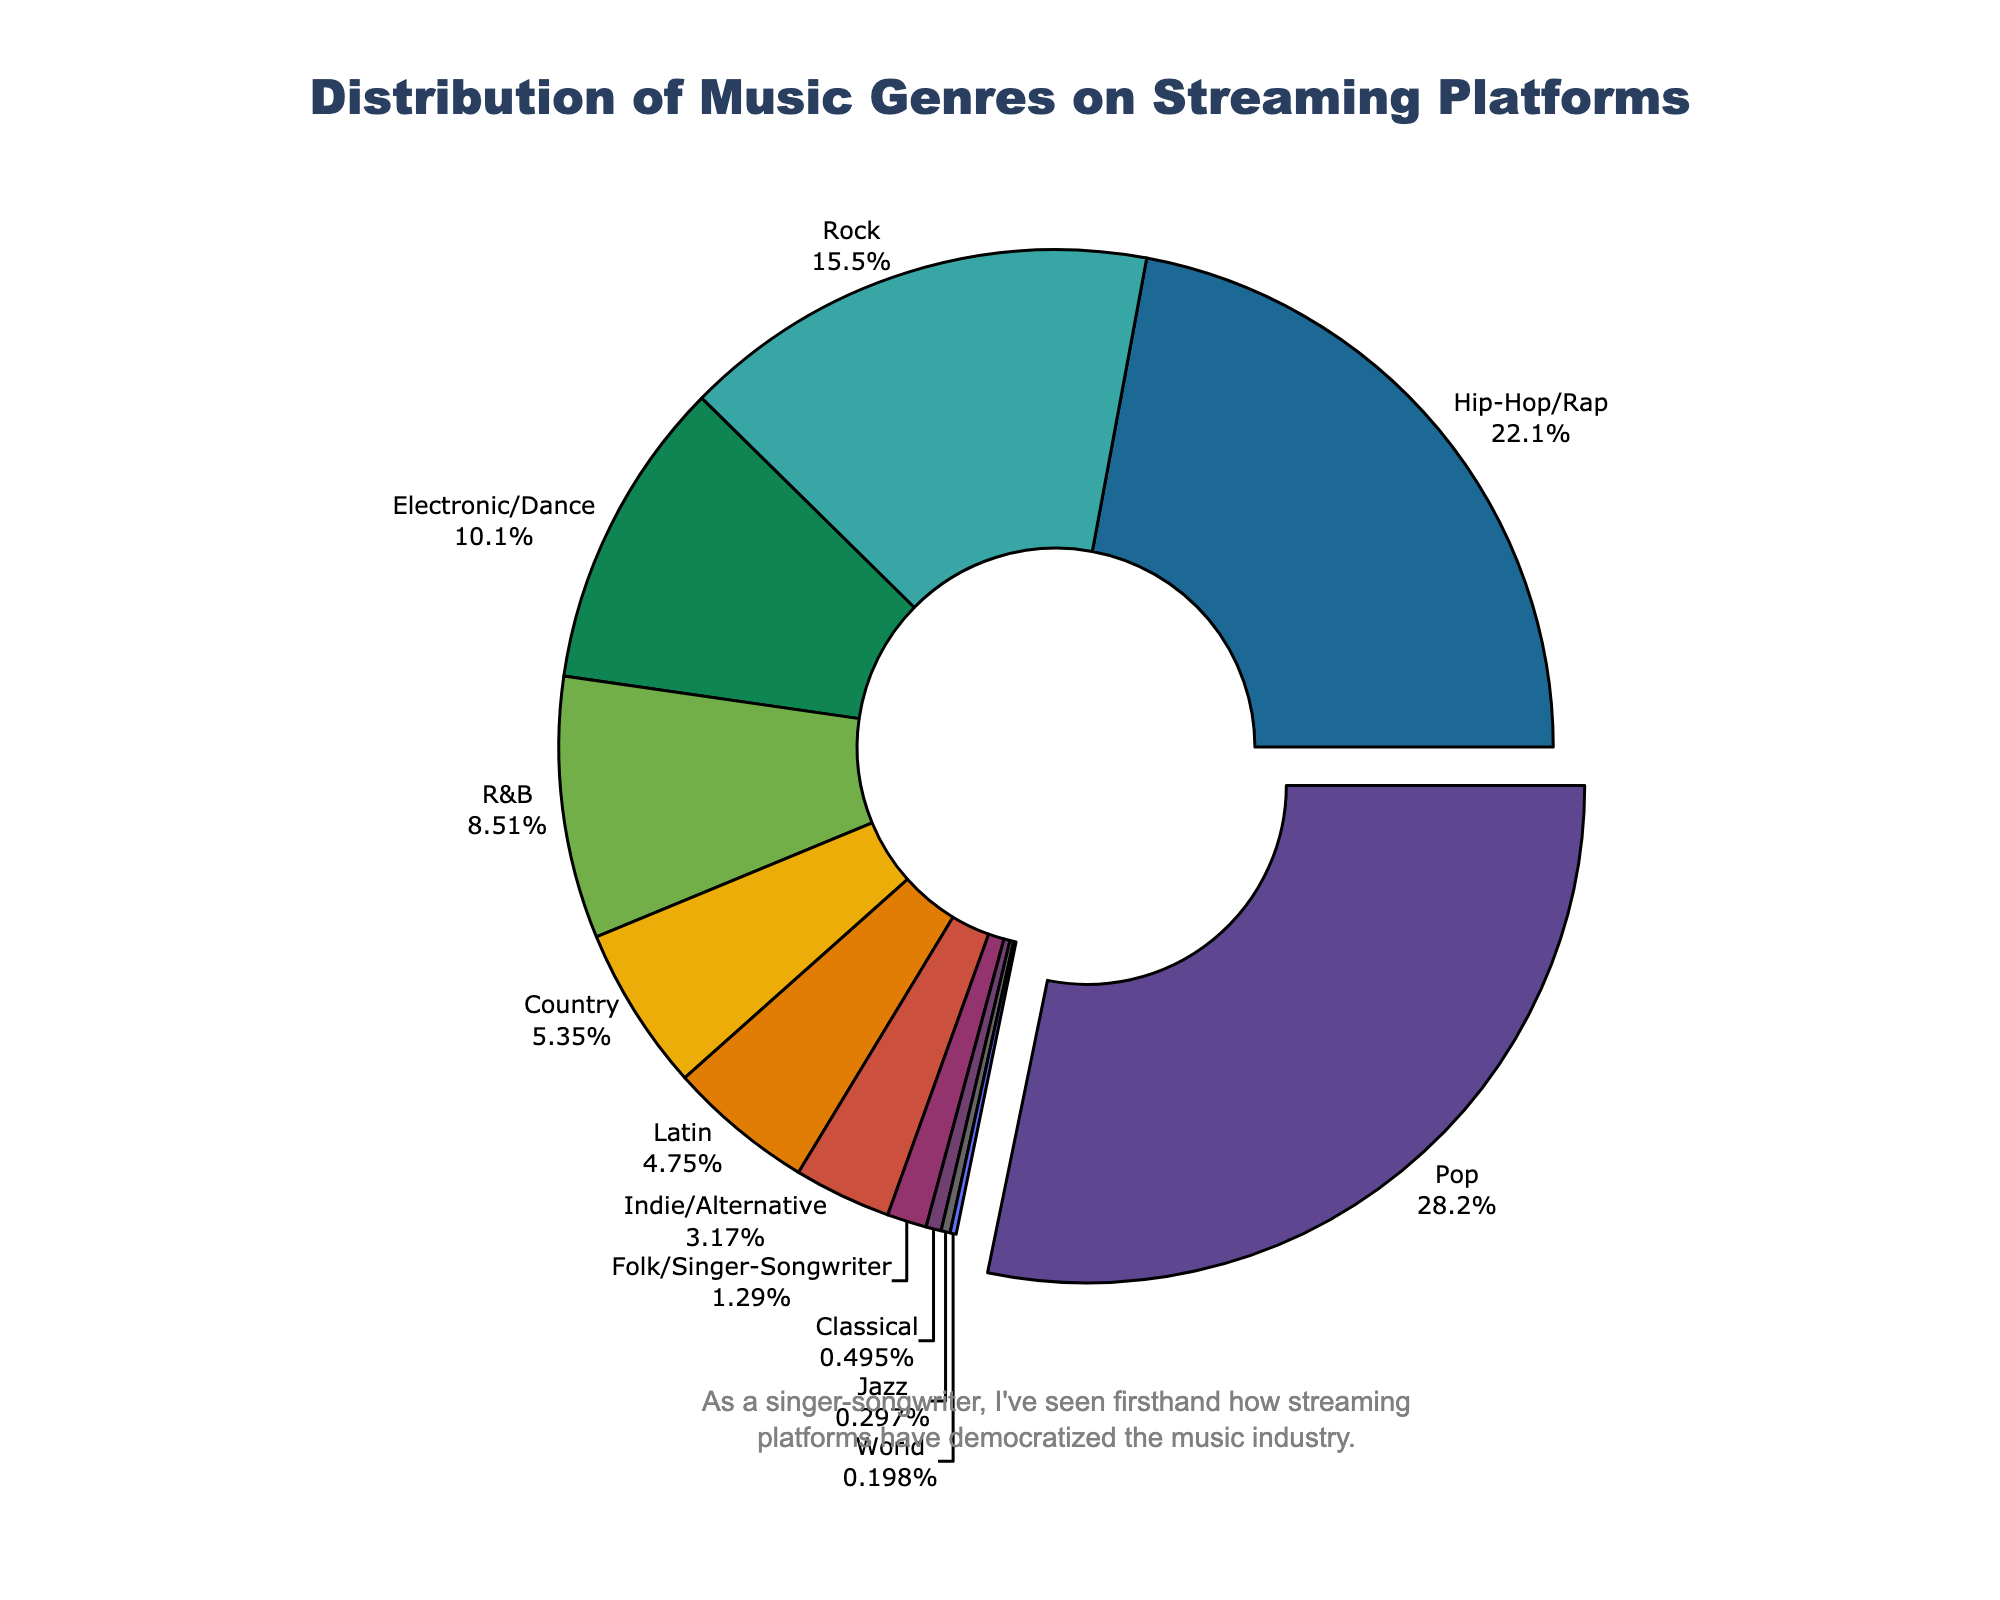what percentage of the total music genres does Pop represent? To find the percentage of Pop, simply look at the sector of the pie chart labeled "Pop" and read the percentage value beside it.
Answer: 28.5% Which genre shows the smallest representation on the pie chart? The smallest representation can be found by identifying the smallest sector on the pie chart and reading its label.
Answer: World What is the combined percentage of Electronic/Dance, Country, and Jazz genres? Add the percentages of Electronic/Dance (10.2%), Country (5.4%), and Jazz (0.3%): 10.2 + 5.4 + 0.3 = 15.9%
Answer: 15.9% How does the percentage of Hip-Hop/Rap compare to that of Rock? Compare the percentages displayed on the chart. Hip-Hop/Rap is 22.3%, and Rock is 15.7%. Therefore, Hip-Hop/Rap is greater.
Answer: Hip-Hop/Rap is greater Is Classical music more or less represented than Folk/Singer-Songwriter? Compare the percentages of Classical (0.5%) and Folk/Singer-Songwriter (1.3%) directly from the pie chart segments.
Answer: Less Which genre occupies the largest section of the pie chart? The genre with the largest section has the highest percentage value, which is annotated on the pie chart.
Answer: Pop If you combine Pop and Hip-Hop/Rap, what is their total representation percentage? Sum the percentages of Pop (28.5%) and Hip-Hop/Rap (22.3%): 28.5 + 22.3 = 50.8%
Answer: 50.8% What is the difference in percentage between R&B and Latin genres? Subtract the percentage of Latin (4.8%) from R&B’s percentage (8.6%): 8.6 - 4.8 = 3.8%
Answer: 3.8% Does Indie/Alternative hold a higher percentage than Classical and Jazz combined? Find the sum of Classical (0.5%) and Jazz (0.3%) which is 0.5 + 0.3 = 0.8%. Then compare it to Indie/Alternative’s percentage (3.2%). 3.2% is greater than 0.8%.
Answer: Yes What is the total percentage representation for genres less than Rock? Identify genres less than Rock and sum their percentages: Electronic/Dance (10.2%), R&B (8.6%), Country (5.4%), Latin (4.8%), Indie/Alternative (3.2%), Folk/Singer-Songwriter (1.3%), Classical (0.5%), Jazz (0.3%), World (0.2%). Sum is 10.2 + 8.6 + 5.4 + 4.8 + 3.2 + 1.3 + 0.5 + 0.3 + 0.2 = 34.5%
Answer: 34.5% 